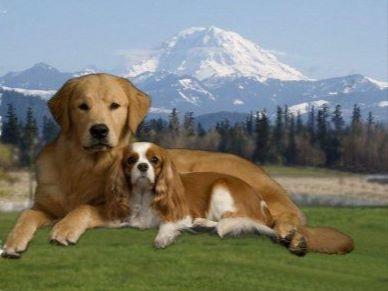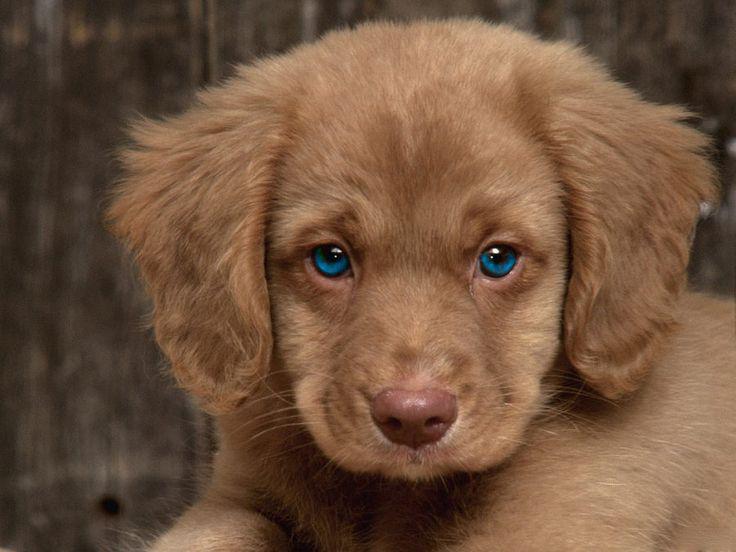The first image is the image on the left, the second image is the image on the right. Considering the images on both sides, is "The right image contains at least two dogs." valid? Answer yes or no. No. The first image is the image on the left, the second image is the image on the right. Analyze the images presented: Is the assertion "The left image features one golden retriever and one brown and white colored cocker spaniel" valid? Answer yes or no. Yes. 